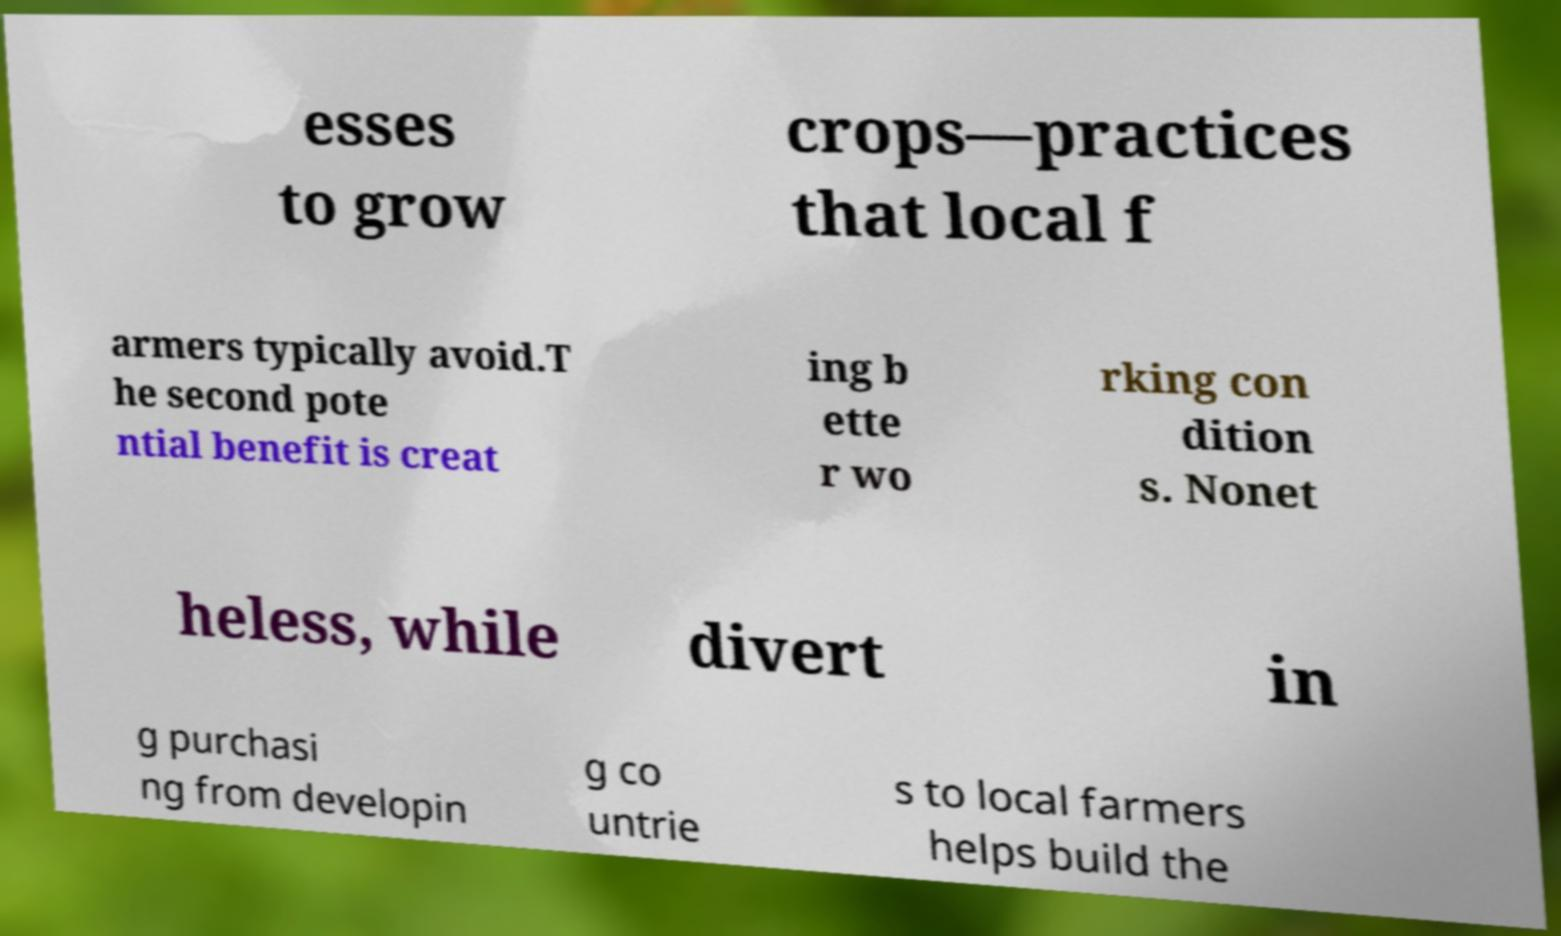Can you read and provide the text displayed in the image?This photo seems to have some interesting text. Can you extract and type it out for me? esses to grow crops—practices that local f armers typically avoid.T he second pote ntial benefit is creat ing b ette r wo rking con dition s. Nonet heless, while divert in g purchasi ng from developin g co untrie s to local farmers helps build the 